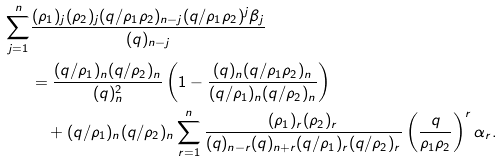Convert formula to latex. <formula><loc_0><loc_0><loc_500><loc_500>\sum _ { j = 1 } ^ { n } & \frac { ( \rho _ { 1 } ) _ { j } ( \rho _ { 2 } ) _ { j } ( q / \rho _ { 1 } \rho _ { 2 } ) _ { n - j } ( q / \rho _ { 1 } \rho _ { 2 } ) ^ { j } \beta _ { j } } { ( q ) _ { n - j } } \\ & = \frac { ( q / \rho _ { 1 } ) _ { n } ( q / \rho _ { 2 } ) _ { n } } { ( q ) _ { n } ^ { 2 } } \left ( 1 - \frac { ( q ) _ { n } ( q / \rho _ { 1 } \rho _ { 2 } ) _ { n } } { ( q / \rho _ { 1 } ) _ { n } ( q / \rho _ { 2 } ) _ { n } } \right ) \\ & \quad + ( q / \rho _ { 1 } ) _ { n } ( q / \rho _ { 2 } ) _ { n } \sum _ { r = 1 } ^ { n } \frac { ( \rho _ { 1 } ) _ { r } ( \rho _ { 2 } ) _ { r } } { ( q ) _ { n - r } ( q ) _ { n + r } ( q / \rho _ { 1 } ) _ { r } ( q / \rho _ { 2 } ) _ { r } } \left ( \frac { q } { \rho _ { 1 } \rho _ { 2 } } \right ) ^ { r } \alpha _ { r } .</formula> 